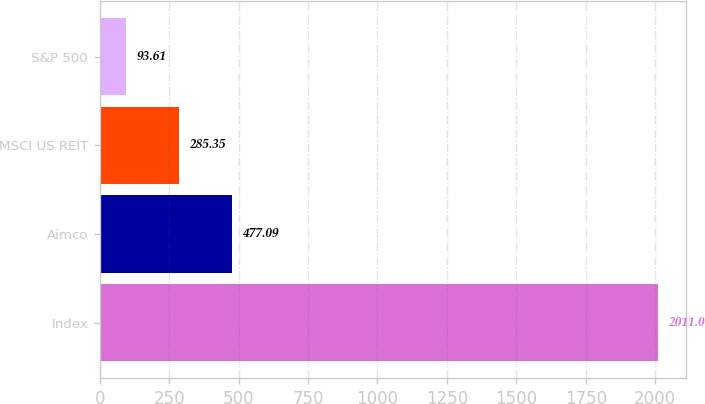Convert chart. <chart><loc_0><loc_0><loc_500><loc_500><bar_chart><fcel>Index<fcel>Aimco<fcel>MSCI US REIT<fcel>S&P 500<nl><fcel>2011<fcel>477.09<fcel>285.35<fcel>93.61<nl></chart> 